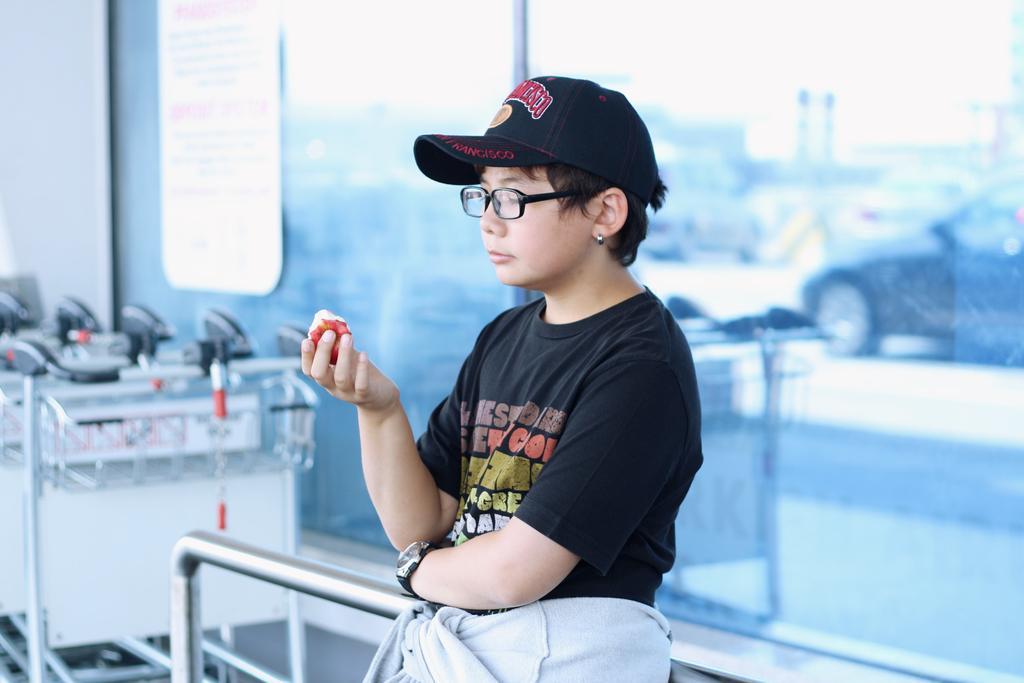Describe this image in one or two sentences. This person wore spectacles, cap and holding food. Board is on glass. These are carts. On this glass there is a reflection of a vehicle. 